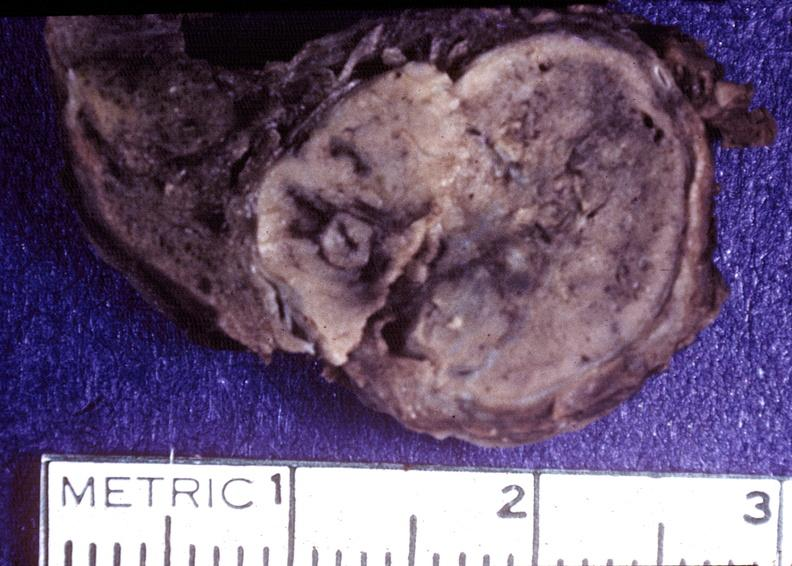what is present?
Answer the question using a single word or phrase. Endocrine 